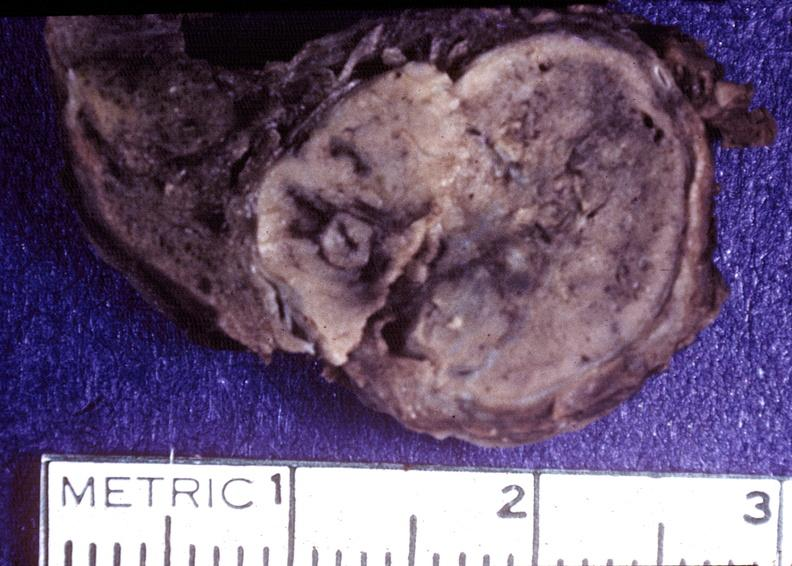what is present?
Answer the question using a single word or phrase. Endocrine 